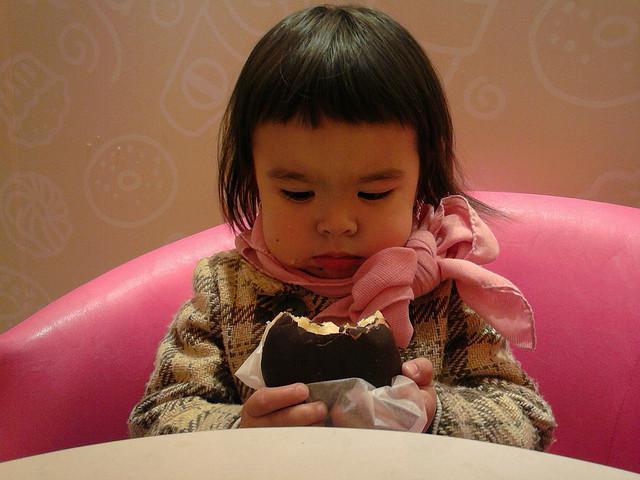Is this affirmation: "The donut is touching the person." correct?
Answer yes or no. Yes. 